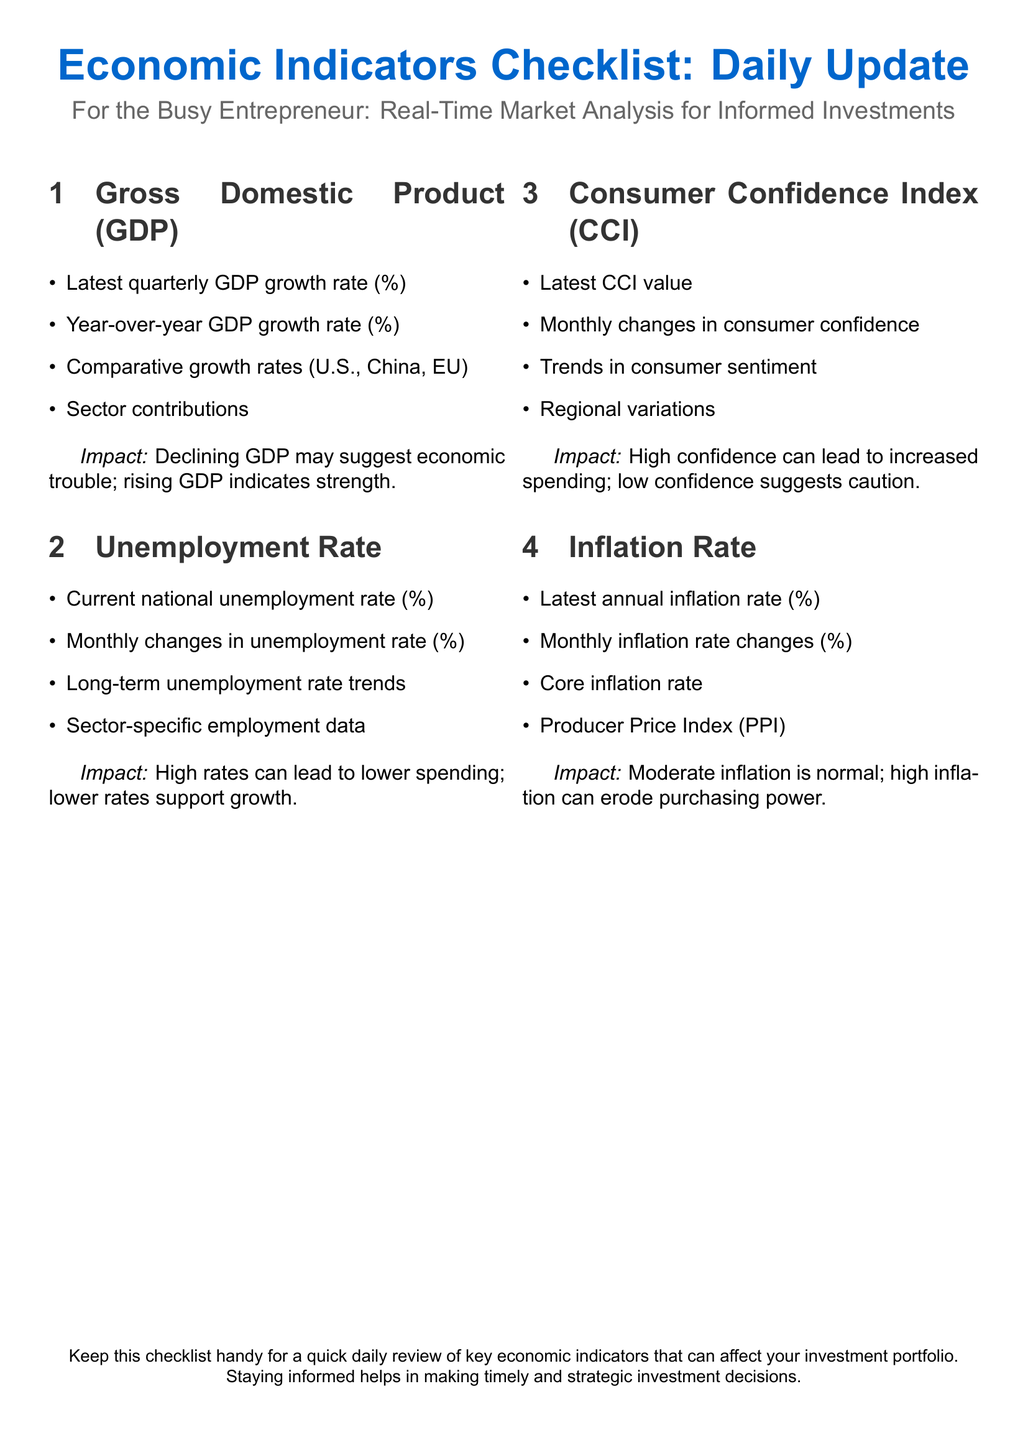what is the latest quarterly GDP growth rate percentage? The document mentions the latest quarterly GDP growth rate should be checked, but does not provide a specific number.
Answer: Not provided what does a declining GDP suggest? The document states that a declining GDP may suggest economic trouble.
Answer: Economic trouble what is the current national unemployment rate? The document refers to the current national unemployment rate needing to be reviewed, but does not specify a number.
Answer: Not provided what is indicated by high consumer confidence? The document suggests that high confidence can lead to increased spending.
Answer: Increased spending what does the latest annual inflation rate percentage indicate? The document instructs to check the latest annual inflation rate, but no specific percentage is given.
Answer: Not provided which index is mentioned alongside the inflation rate? The document lists the Producer Price Index (PPI) as related to inflation.
Answer: Producer Price Index what effect does a high unemployment rate have on spending? The document states that high rates can lead to lower spending.
Answer: Lower spending what are sector contributions related to in the GDP section? The document mentions sector contributions as part of the GDP analysis but does not specify the sectors.
Answer: Not provided what are the monthly changes in unemployment rate? The document requests checking the monthly changes but does not offer a numerical figure.
Answer: Not provided 